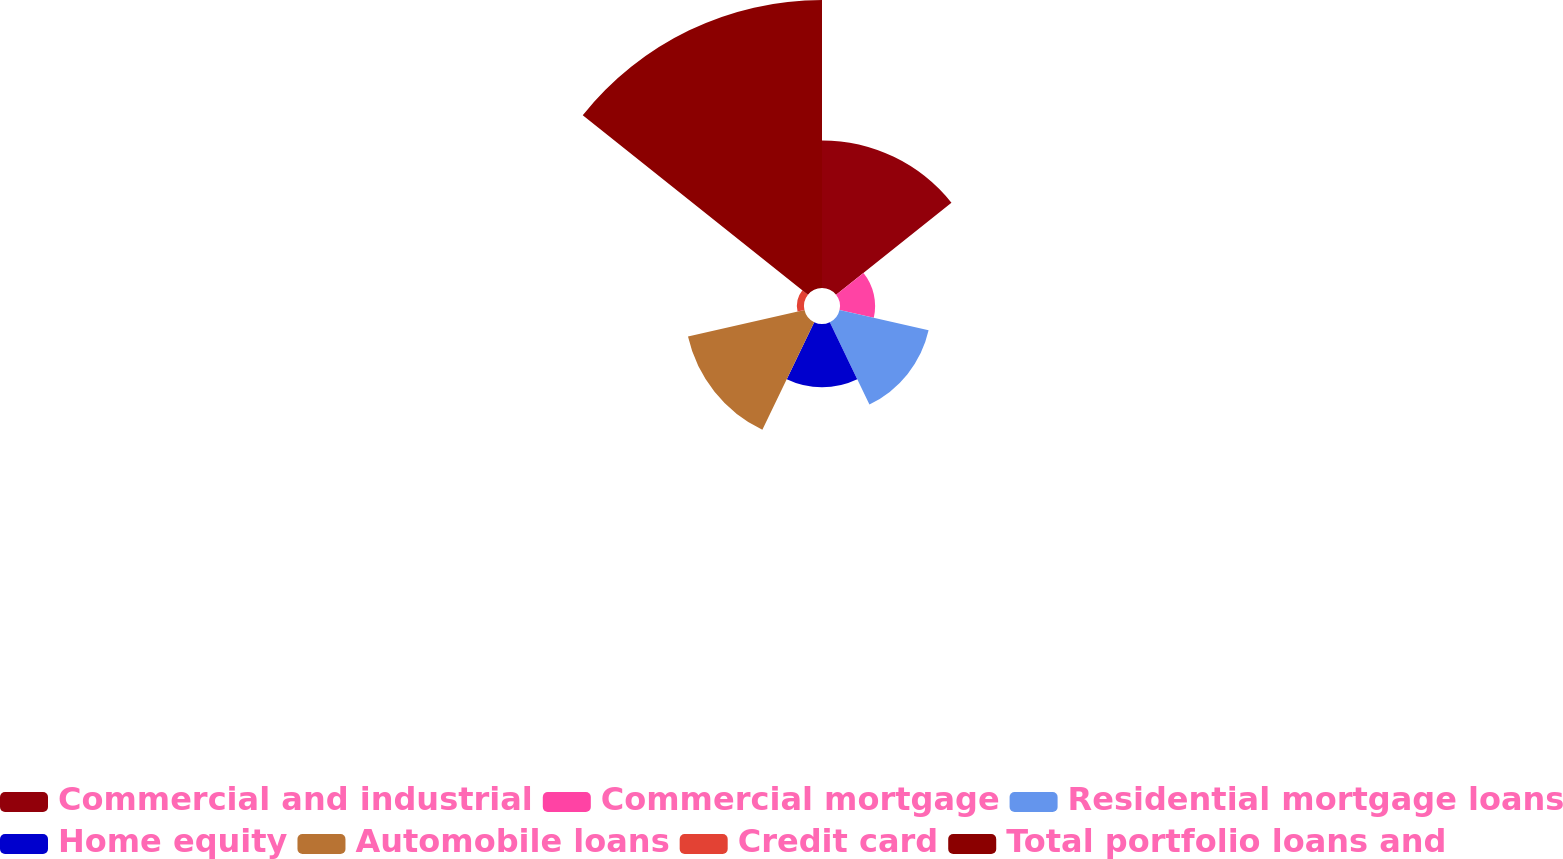Convert chart. <chart><loc_0><loc_0><loc_500><loc_500><pie_chart><fcel>Commercial and industrial<fcel>Commercial mortgage<fcel>Residential mortgage loans<fcel>Home equity<fcel>Automobile loans<fcel>Credit card<fcel>Total portfolio loans and<nl><fcel>19.63%<fcel>4.67%<fcel>12.15%<fcel>8.41%<fcel>15.89%<fcel>0.94%<fcel>38.31%<nl></chart> 